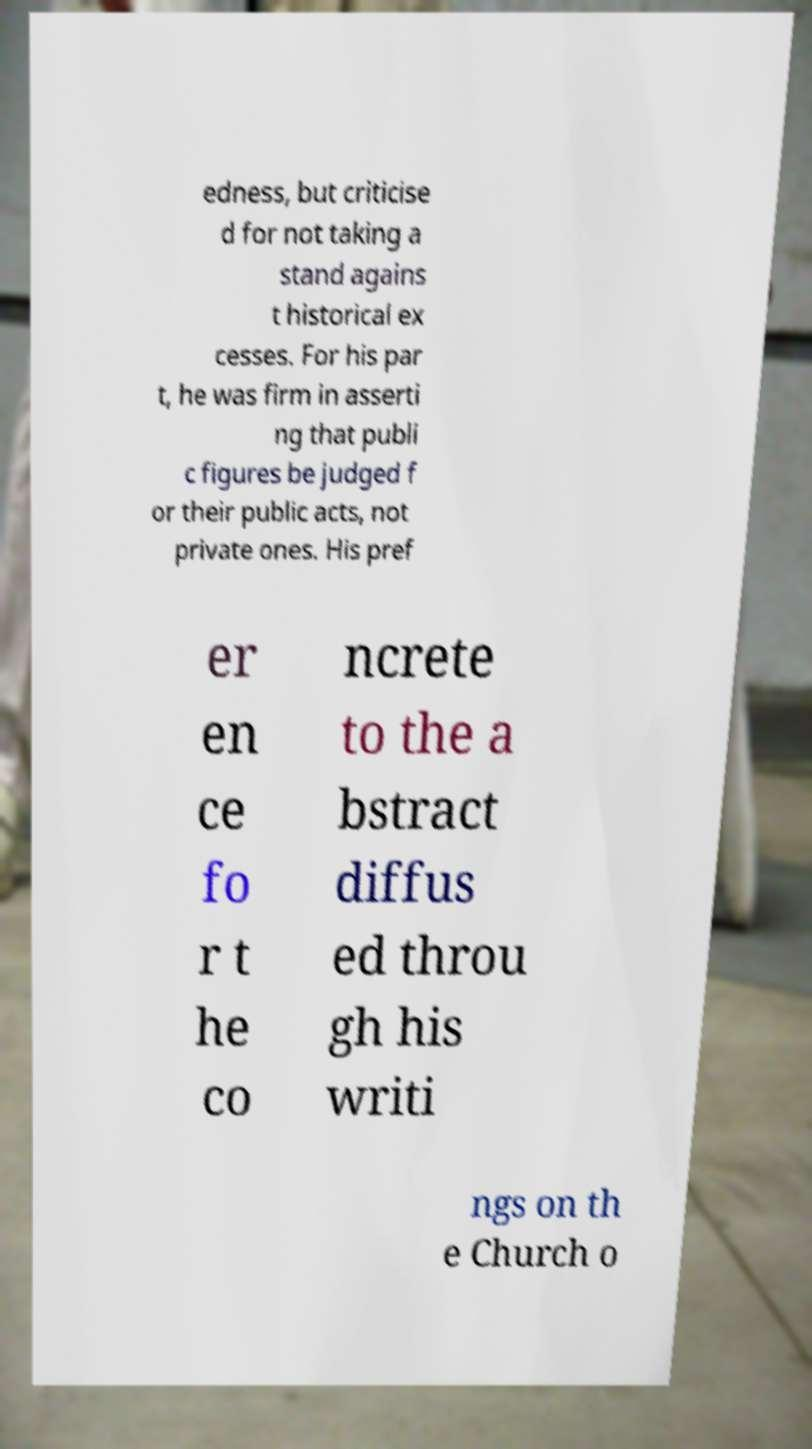What messages or text are displayed in this image? I need them in a readable, typed format. edness, but criticise d for not taking a stand agains t historical ex cesses. For his par t, he was firm in asserti ng that publi c figures be judged f or their public acts, not private ones. His pref er en ce fo r t he co ncrete to the a bstract diffus ed throu gh his writi ngs on th e Church o 